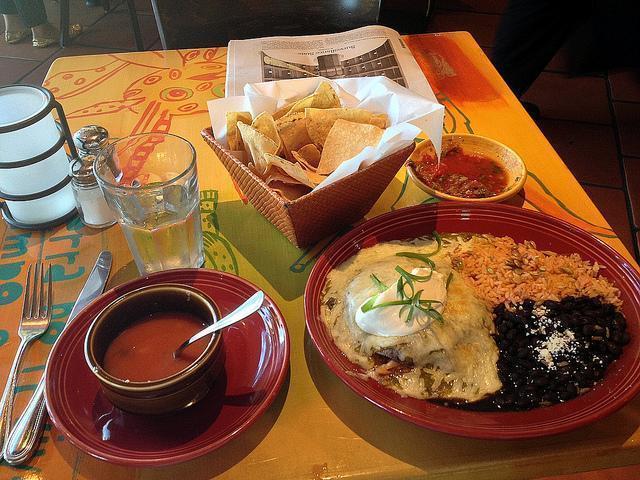How many people will dine at this table?
Choose the correct response and explain in the format: 'Answer: answer
Rationale: rationale.'
Options: Two, five, none, one. Answer: one.
Rationale: There is only food for one person. 